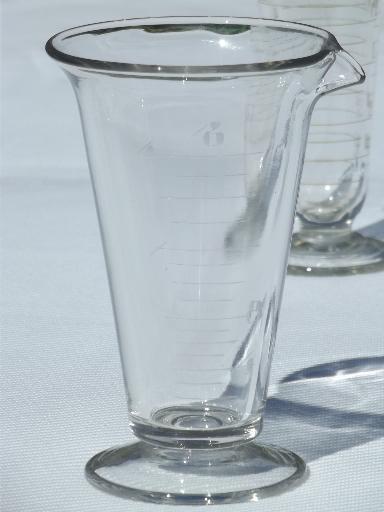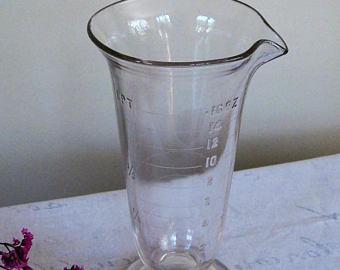The first image is the image on the left, the second image is the image on the right. Considering the images on both sides, is "One image shows two footed beakers of the same height and one shorter footed beaker, all displayed upright." valid? Answer yes or no. No. 